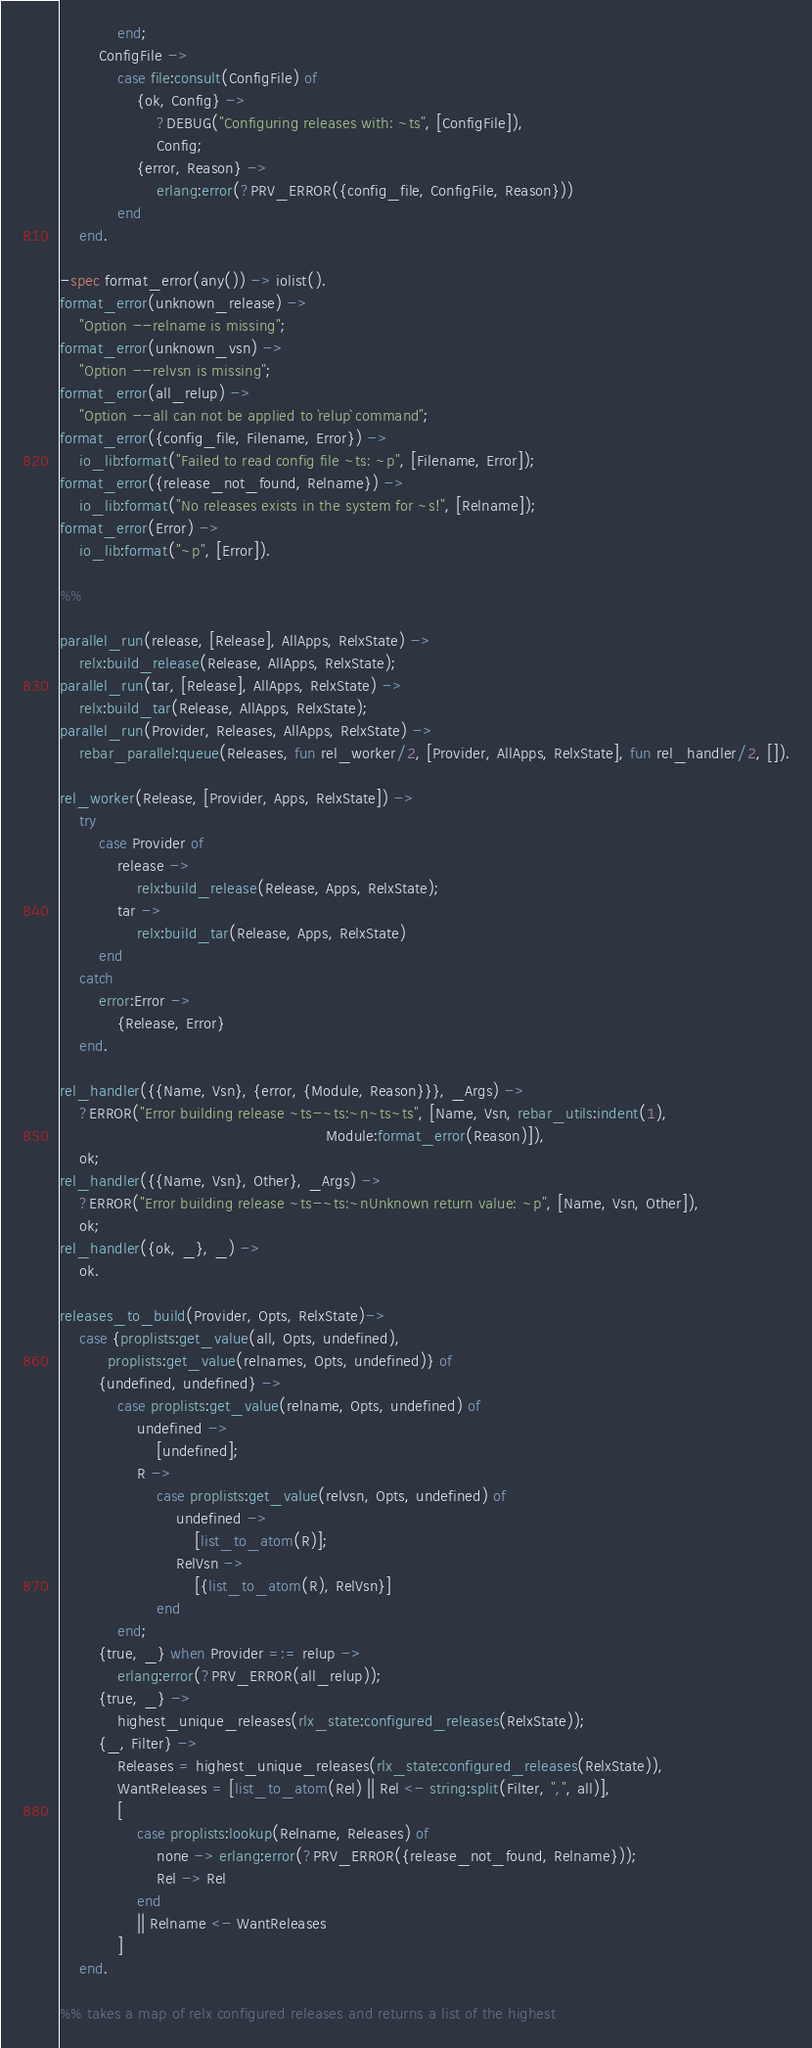Convert code to text. <code><loc_0><loc_0><loc_500><loc_500><_Erlang_>            end;
        ConfigFile ->
            case file:consult(ConfigFile) of
                {ok, Config} ->
                    ?DEBUG("Configuring releases with: ~ts", [ConfigFile]),
                    Config;
                {error, Reason} ->
                    erlang:error(?PRV_ERROR({config_file, ConfigFile, Reason}))
            end
    end.

-spec format_error(any()) -> iolist().
format_error(unknown_release) ->
    "Option --relname is missing";
format_error(unknown_vsn) ->
    "Option --relvsn is missing";
format_error(all_relup) ->
    "Option --all can not be applied to `relup` command";
format_error({config_file, Filename, Error}) ->
    io_lib:format("Failed to read config file ~ts: ~p", [Filename, Error]);
format_error({release_not_found, Relname}) ->
    io_lib:format("No releases exists in the system for ~s!", [Relname]);
format_error(Error) ->
    io_lib:format("~p", [Error]).

%%

parallel_run(release, [Release], AllApps, RelxState) ->
    relx:build_release(Release, AllApps, RelxState);
parallel_run(tar, [Release], AllApps, RelxState) ->
    relx:build_tar(Release, AllApps, RelxState);
parallel_run(Provider, Releases, AllApps, RelxState) ->
    rebar_parallel:queue(Releases, fun rel_worker/2, [Provider, AllApps, RelxState], fun rel_handler/2, []).

rel_worker(Release, [Provider, Apps, RelxState]) ->
    try
        case Provider of
            release ->
                relx:build_release(Release, Apps, RelxState);
            tar ->
                relx:build_tar(Release, Apps, RelxState)
        end
    catch
        error:Error ->
            {Release, Error}
    end.

rel_handler({{Name, Vsn}, {error, {Module, Reason}}}, _Args) ->
    ?ERROR("Error building release ~ts-~ts:~n~ts~ts", [Name, Vsn, rebar_utils:indent(1),
                                                       Module:format_error(Reason)]),
    ok;
rel_handler({{Name, Vsn}, Other}, _Args) ->
    ?ERROR("Error building release ~ts-~ts:~nUnknown return value: ~p", [Name, Vsn, Other]),
    ok;
rel_handler({ok, _}, _) ->
    ok.

releases_to_build(Provider, Opts, RelxState)->
    case {proplists:get_value(all, Opts, undefined),
          proplists:get_value(relnames, Opts, undefined)} of
        {undefined, undefined} ->
            case proplists:get_value(relname, Opts, undefined) of
                undefined ->
                    [undefined];
                R ->
                    case proplists:get_value(relvsn, Opts, undefined) of
                        undefined ->
                            [list_to_atom(R)];
                        RelVsn ->
                            [{list_to_atom(R), RelVsn}]
                    end
            end;
        {true, _} when Provider =:= relup ->
            erlang:error(?PRV_ERROR(all_relup));
        {true, _} ->
            highest_unique_releases(rlx_state:configured_releases(RelxState));
        {_, Filter} ->
            Releases = highest_unique_releases(rlx_state:configured_releases(RelxState)),
            WantReleases = [list_to_atom(Rel) || Rel <- string:split(Filter, ",", all)],
            [
                case proplists:lookup(Relname, Releases) of
                    none -> erlang:error(?PRV_ERROR({release_not_found, Relname}));
                    Rel -> Rel
                end
                || Relname <- WantReleases
            ]
    end.

%% takes a map of relx configured releases and returns a list of the highest</code> 